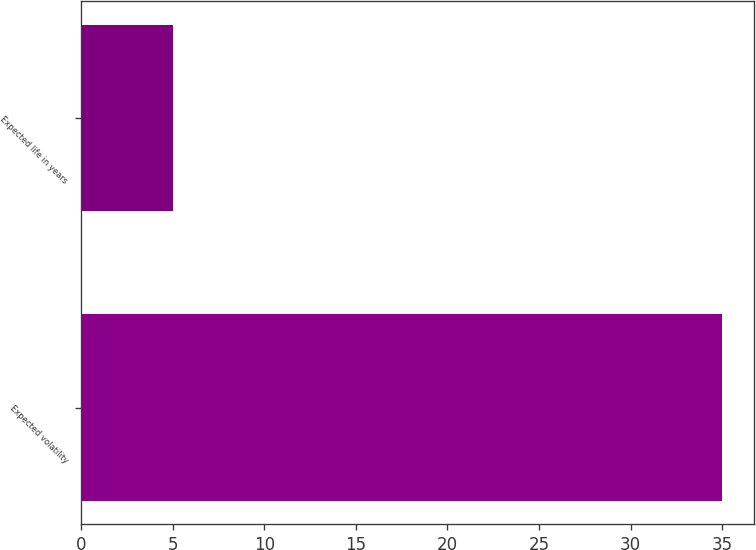<chart> <loc_0><loc_0><loc_500><loc_500><bar_chart><fcel>Expected volatility<fcel>Expected life in years<nl><fcel>35<fcel>5<nl></chart> 